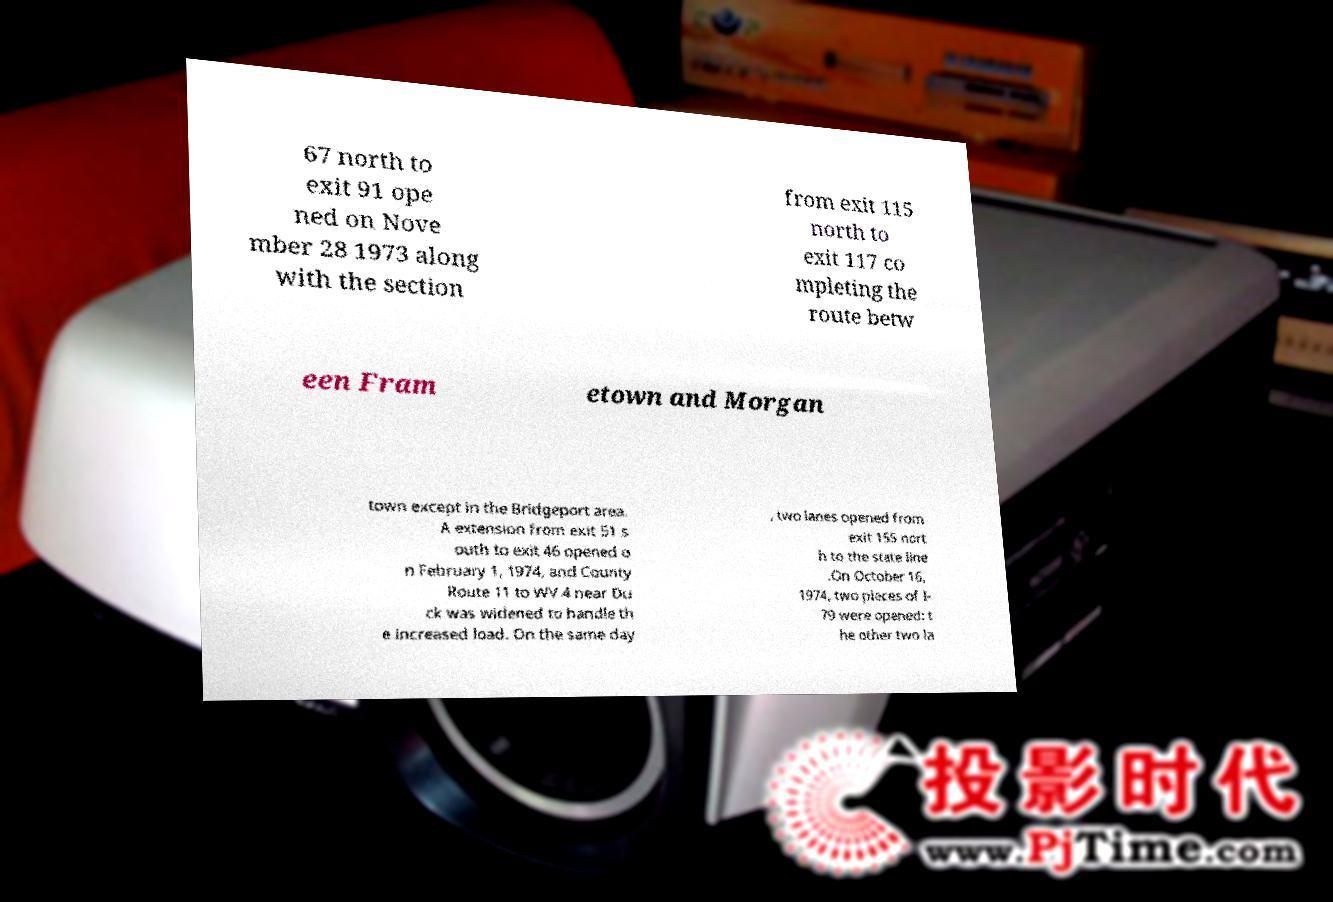Could you assist in decoding the text presented in this image and type it out clearly? 67 north to exit 91 ope ned on Nove mber 28 1973 along with the section from exit 115 north to exit 117 co mpleting the route betw een Fram etown and Morgan town except in the Bridgeport area. A extension from exit 51 s outh to exit 46 opened o n February 1, 1974, and County Route 11 to WV 4 near Du ck was widened to handle th e increased load. On the same day , two lanes opened from exit 155 nort h to the state line .On October 16, 1974, two pieces of I- 79 were opened: t he other two la 